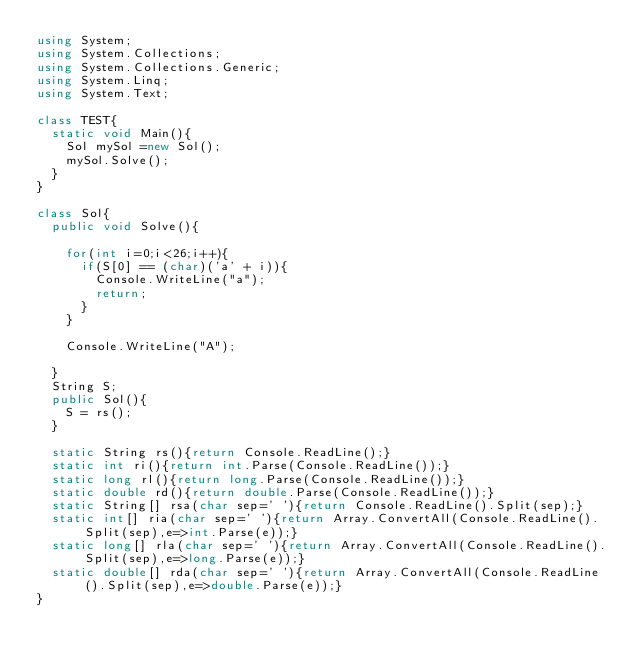Convert code to text. <code><loc_0><loc_0><loc_500><loc_500><_C#_>using System;
using System.Collections;
using System.Collections.Generic;
using System.Linq;
using System.Text;

class TEST{
	static void Main(){
		Sol mySol =new Sol();
		mySol.Solve();
	}
}

class Sol{
	public void Solve(){
		
		for(int i=0;i<26;i++){
			if(S[0] == (char)('a' + i)){
				Console.WriteLine("a");
				return;
			}
		}
		
		Console.WriteLine("A");
		
	}
	String S;
	public Sol(){
		S = rs();
	}

	static String rs(){return Console.ReadLine();}
	static int ri(){return int.Parse(Console.ReadLine());}
	static long rl(){return long.Parse(Console.ReadLine());}
	static double rd(){return double.Parse(Console.ReadLine());}
	static String[] rsa(char sep=' '){return Console.ReadLine().Split(sep);}
	static int[] ria(char sep=' '){return Array.ConvertAll(Console.ReadLine().Split(sep),e=>int.Parse(e));}
	static long[] rla(char sep=' '){return Array.ConvertAll(Console.ReadLine().Split(sep),e=>long.Parse(e));}
	static double[] rda(char sep=' '){return Array.ConvertAll(Console.ReadLine().Split(sep),e=>double.Parse(e));}
}
</code> 